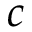<formula> <loc_0><loc_0><loc_500><loc_500>c</formula> 